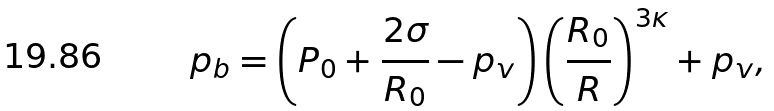<formula> <loc_0><loc_0><loc_500><loc_500>p _ { b } = \left ( { P _ { 0 } + \frac { 2 \sigma } { R _ { 0 } } - p _ { v } } \right ) \left ( { \frac { R _ { 0 } } { R } } \right ) ^ { 3 \kappa } + p _ { v } ,</formula> 